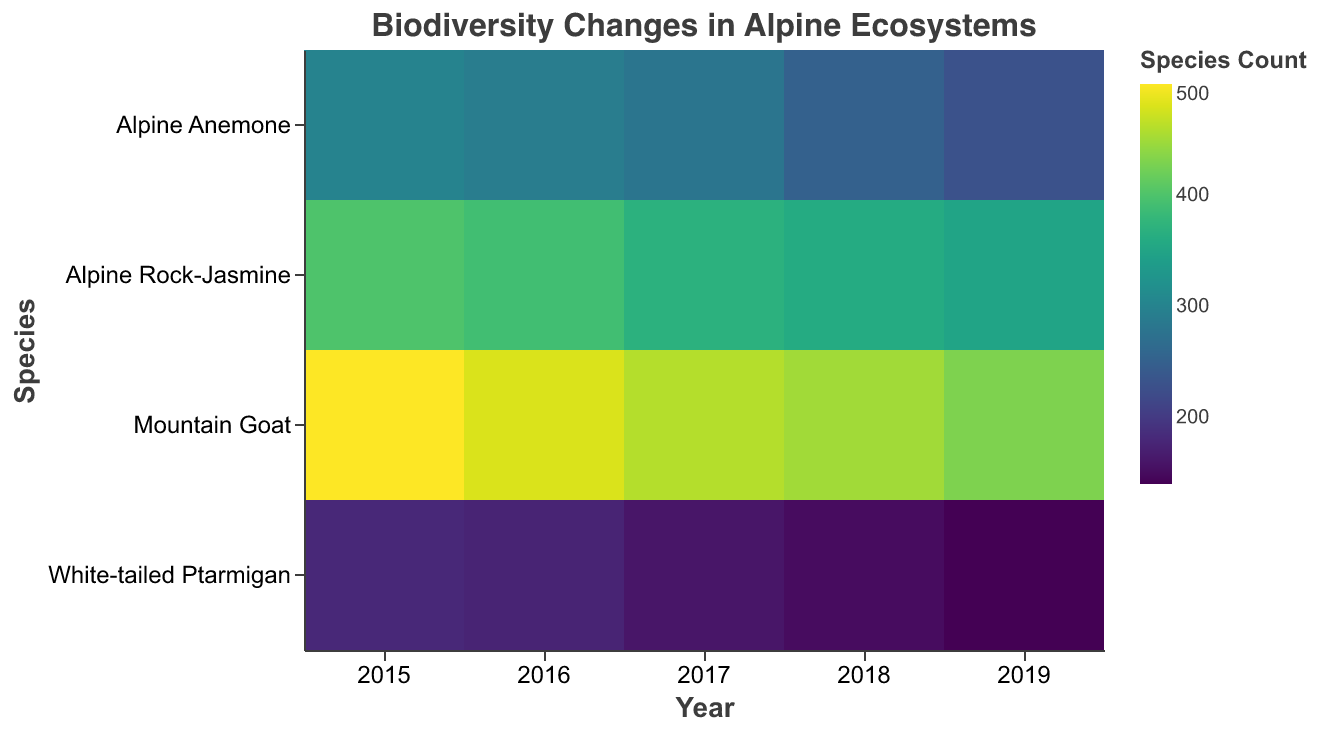What's the title of the figure? The title of the figure is displayed at the top and is the description of what the figure represents.
Answer: Biodiversity Changes in Alpine Ecosystems How many species are depicted in the heatmap? The species are listed on the y-axis of the heatmap, one per row. Counting these rows gives the total number of species.
Answer: 4 Which year had the highest species count for the Mountain Goat? Look at the row for Mountain Goat and identify the column (year) with the darkest color, indicating the highest species count.
Answer: 2015 What is the average snow cover for White-tailed Ptarmigan in 2017? Find the cell corresponding to the White-tailed Ptarmigan and 2017. The tooltip should provide this information.
Answer: 85 cm Which species experienced the largest decrease in species count from 2015 to 2019? Compare the species counts for each species between 2015 and 2019 and calculate the differences. The species with the largest negative difference is the answer.
Answer: Alpine Anemone How does the species count for the Alpine Rock-Jasmine in 2016 compare to its count in 2018? Find the cells for Alpine Rock-Jasmine in 2016 and 2018 and compare their species counts provided in the tooltip.
Answer: 2016: 390, 2018: 360 What trend can be observed for the species count of the White-tailed Ptarmigan over the years? Look at the cells corresponding to White-tailed Ptarmigan across the years. Observe the changing colors to determine if the count increases, decreases, or remains stable.
Answer: Decreasing trend In which location was the average snow cover the highest in 2015? Check the tooltip information for the average snow cover values for each location in 2015 and identify the highest one.
Answer: Rocky Mountains What pattern can be observed between snow cover and species count for the Alpine Anemone? Examine Alpine Anemone's cells across the years, looking at the provided snow cover and species count. Identify the correlation between decreasing snow cover and species count.
Answer: Decreasing snow cover correlates with decreasing species count Compare the species count of White-tailed Ptarmigan and Mountain Goat in 2017. Locate the cells for both species in the year 2017 and compare their species counts from the tooltips.
Answer: White-tailed Ptarmigan: 160, Mountain Goat: 460 